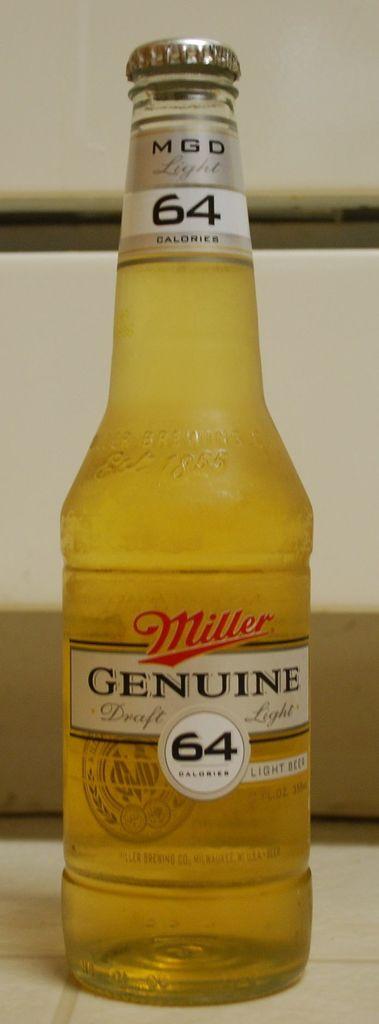What brand of beer is this bottle?
Make the answer very short. Miller. What number is written on the bottle?
Your answer should be very brief. 64. 